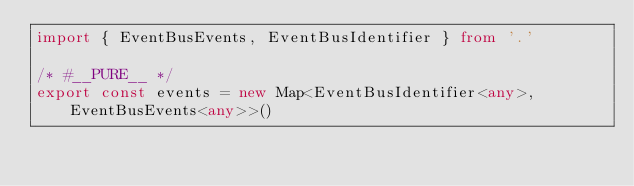<code> <loc_0><loc_0><loc_500><loc_500><_TypeScript_>import { EventBusEvents, EventBusIdentifier } from '.'

/* #__PURE__ */
export const events = new Map<EventBusIdentifier<any>, EventBusEvents<any>>()
</code> 